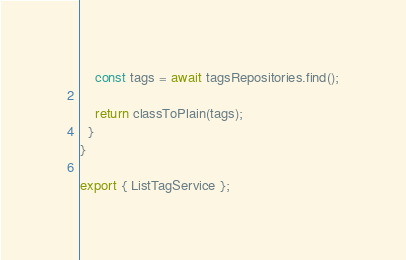<code> <loc_0><loc_0><loc_500><loc_500><_TypeScript_>
    const tags = await tagsRepositories.find();

    return classToPlain(tags);
  }
}

export { ListTagService };
</code> 